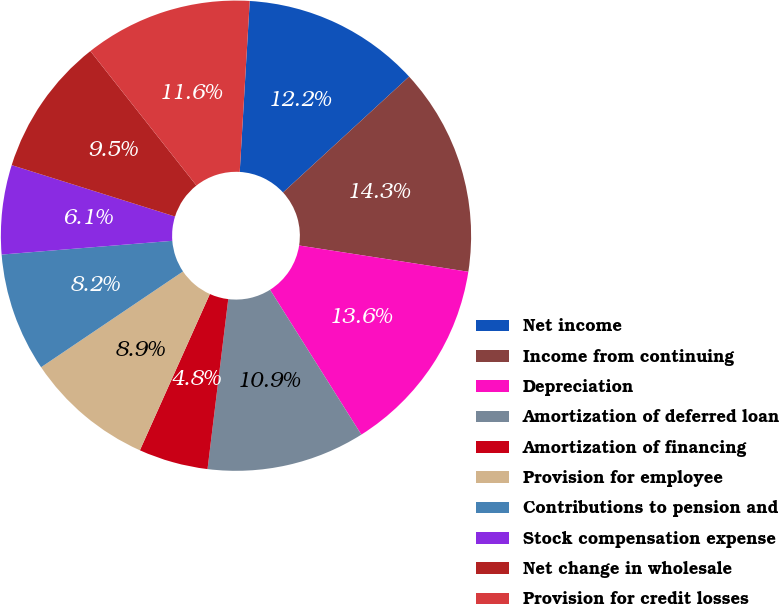Convert chart. <chart><loc_0><loc_0><loc_500><loc_500><pie_chart><fcel>Net income<fcel>Income from continuing<fcel>Depreciation<fcel>Amortization of deferred loan<fcel>Amortization of financing<fcel>Provision for employee<fcel>Contributions to pension and<fcel>Stock compensation expense<fcel>Net change in wholesale<fcel>Provision for credit losses<nl><fcel>12.24%<fcel>14.28%<fcel>13.6%<fcel>10.88%<fcel>4.77%<fcel>8.85%<fcel>8.17%<fcel>6.13%<fcel>9.52%<fcel>11.56%<nl></chart> 